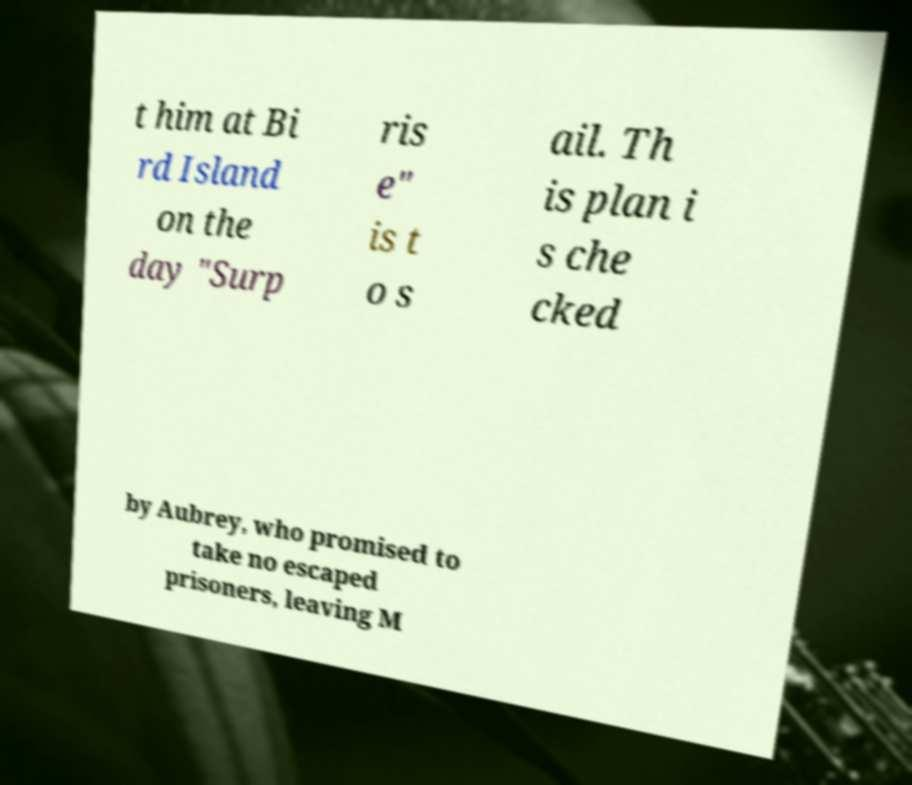What messages or text are displayed in this image? I need them in a readable, typed format. t him at Bi rd Island on the day "Surp ris e" is t o s ail. Th is plan i s che cked by Aubrey, who promised to take no escaped prisoners, leaving M 